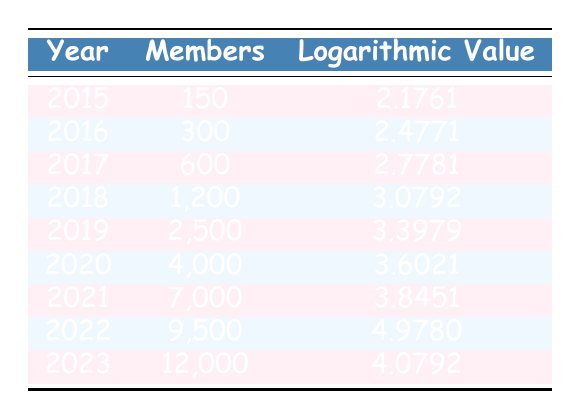What was the membership count in 2017? In the table, the row for 2017 lists the membership count as 600.
Answer: 600 What is the logarithmic value for 2020? The table shows that the logarithmic value for 2020 is 3.6021, found in the row corresponding to that year.
Answer: 3.6021 Which year saw the highest membership count? Looking at the membership counts for each year, 2023 has the highest count at 12,000.
Answer: 2023 What was the growth in membership from 2015 to 2021? In 2015, the membership count was 150, and in 2021 it was 7,000. The growth is 7,000 - 150 = 6,850.
Answer: 6,850 Is the logarithmic value for 2022 greater than that for 2021? The logarithmic value for 2022 is 4.9780, and for 2021 it is 3.8451. Since 4.9780 is greater than 3.8451, the statement is true.
Answer: Yes What is the average number of members from 2015 to 2019? To find the average, we sum the members for those years: 150 + 300 + 600 + 1200 + 2500 = 3750, then divide by 5, which equals 750.
Answer: 750 Which year had a membership count of 9,500? The table shows that the membership count of 9,500 corresponds to the year 2022.
Answer: 2022 How much did membership increase from 2016 to 2018? In 2016 the membership was 300 and in 2018 it was 1,200. The increase is 1,200 - 300 = 900 members.
Answer: 900 Was the membership count in 2019 less than 10,000? The membership count for 2019 is 2,500, which is indeed less than 10,000, making the statement true.
Answer: Yes 